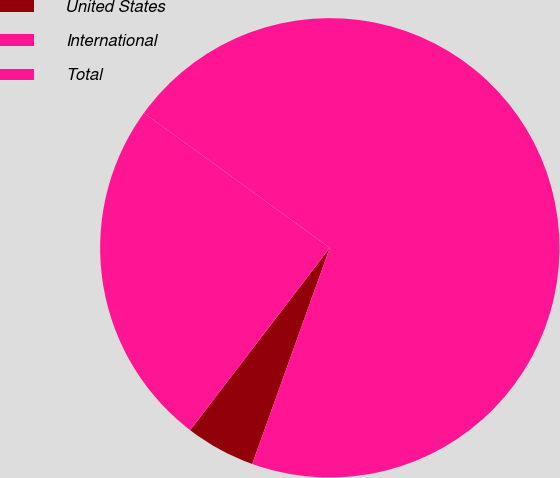<chart> <loc_0><loc_0><loc_500><loc_500><pie_chart><fcel>United States<fcel>International<fcel>Total<nl><fcel>4.92%<fcel>70.49%<fcel>24.59%<nl></chart> 